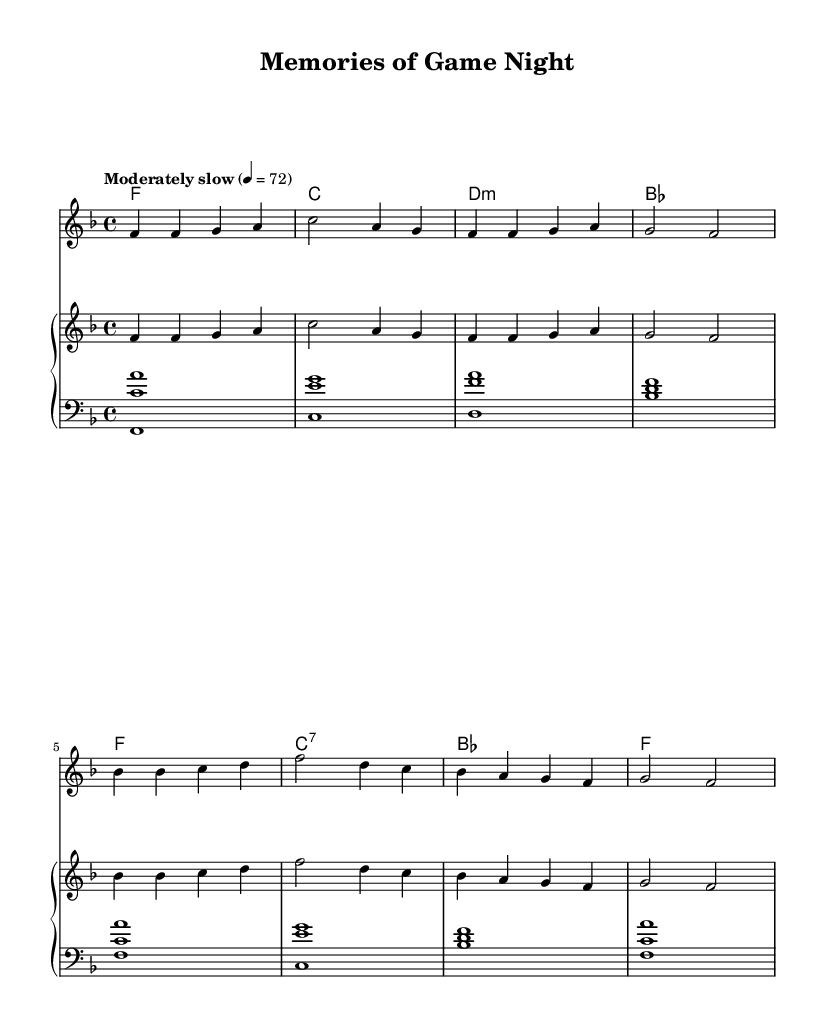What is the key signature of this music? The key signature appears at the beginning of the staff, showing one flat, which indicates it is in F major.
Answer: F major What is the time signature of this music? The time signature is located near the beginning of the staff, showing a 4 over 4, indicating it has four beats per measure.
Answer: 4/4 What is the tempo marking of this music? The tempo marking is indicated at the beginning, stating "Moderately slow" with a metronome marking of 72 beats per minute.
Answer: Moderately slow How many measures are in the melody? By counting the groupings of notes in the melody section, we find 8 measures in total, each separated by a vertical line.
Answer: 8 What chord follows the first F major chord? The first chord in the harmonies section is F major, and the next chord that follows it is C major.
Answer: C major Which musical instrument is specified for the right-hand part? The right-hand part is specified to use an "acoustic grand" instrument under the staff setup for the piano.
Answer: Acoustic grand What harmonic function does the B flat chord serve in this progression? The B flat chord, appearing after the dominant chords, serves as a subdominant in the harmonic progression, transitioning back to the tonic F major in the following measures.
Answer: Subdominant 